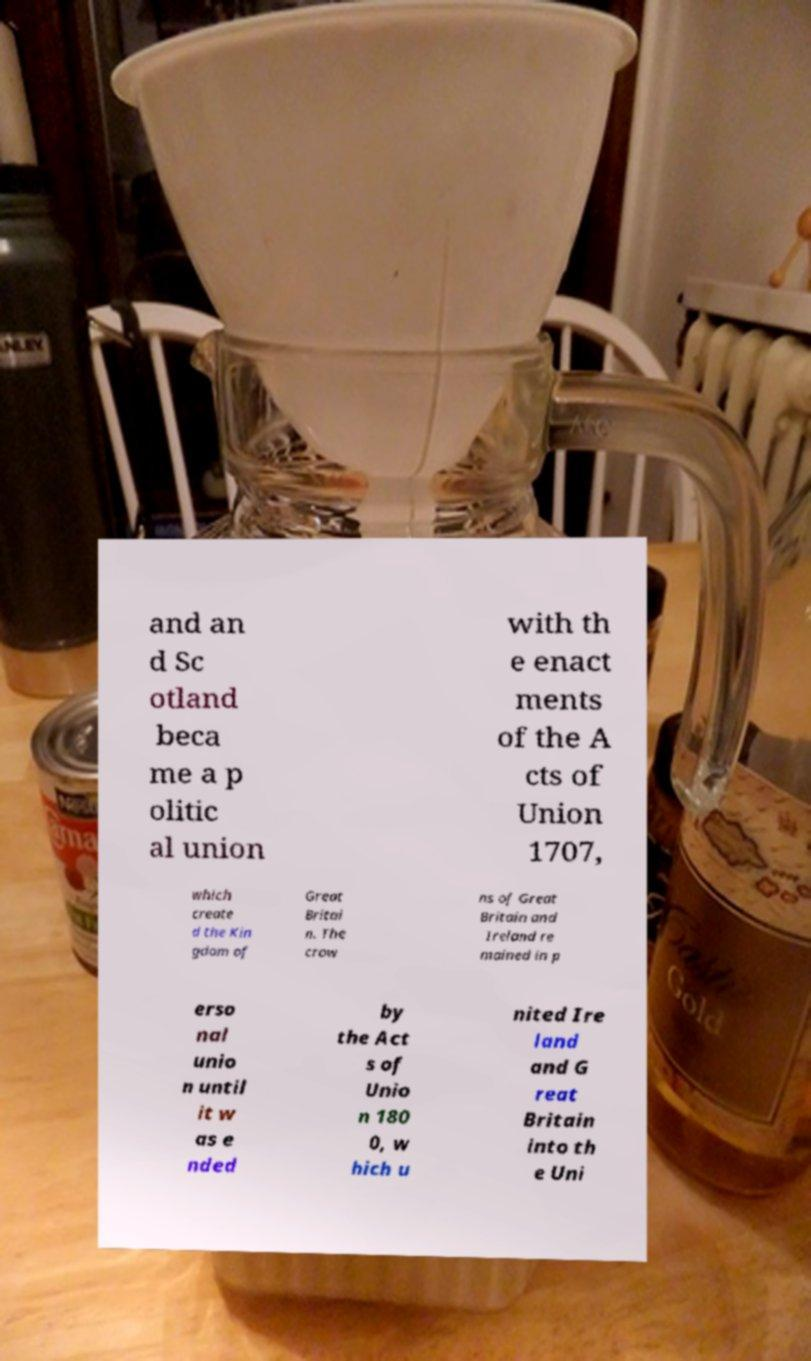Please identify and transcribe the text found in this image. and an d Sc otland beca me a p olitic al union with th e enact ments of the A cts of Union 1707, which create d the Kin gdom of Great Britai n. The crow ns of Great Britain and Ireland re mained in p erso nal unio n until it w as e nded by the Act s of Unio n 180 0, w hich u nited Ire land and G reat Britain into th e Uni 